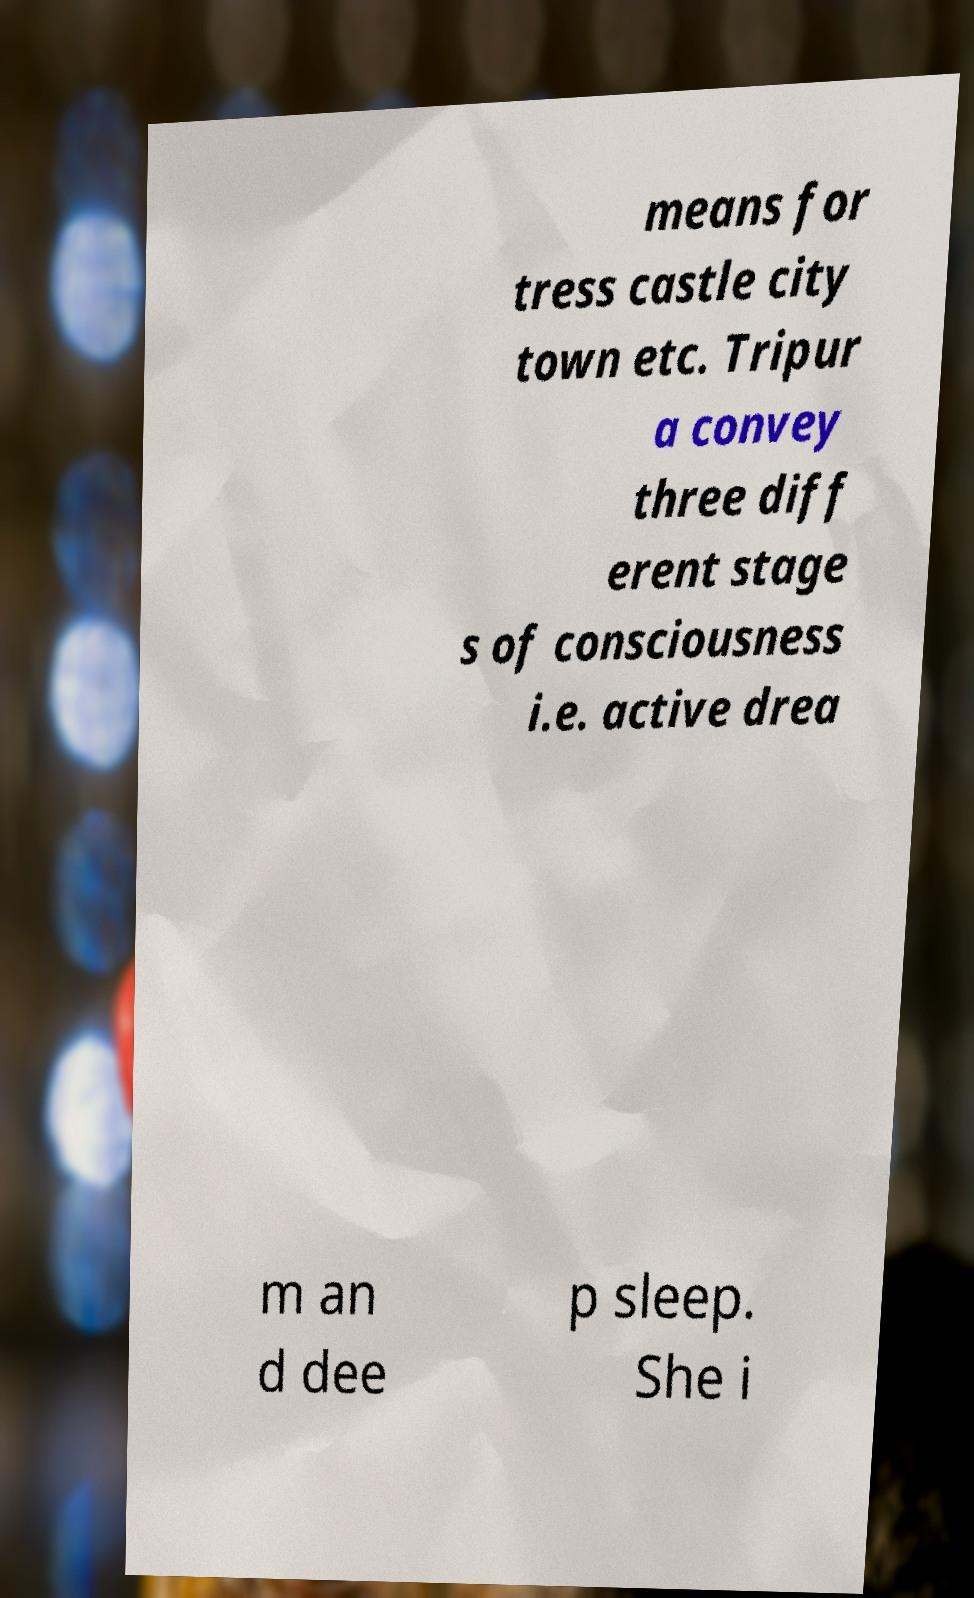For documentation purposes, I need the text within this image transcribed. Could you provide that? means for tress castle city town etc. Tripur a convey three diff erent stage s of consciousness i.e. active drea m an d dee p sleep. She i 